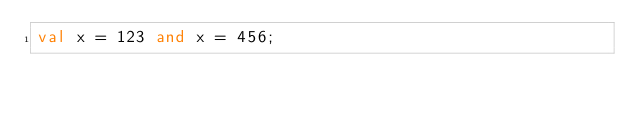<code> <loc_0><loc_0><loc_500><loc_500><_SML_>val x = 123 and x = 456;
</code> 